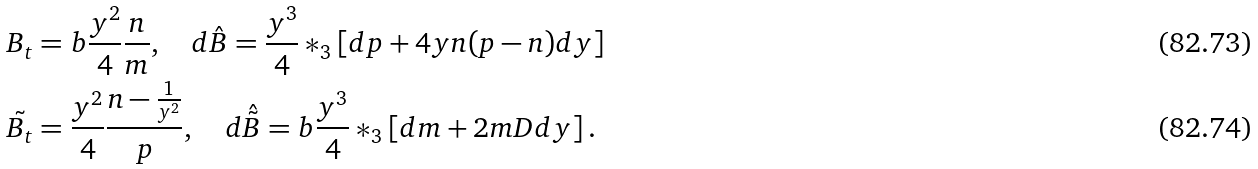<formula> <loc_0><loc_0><loc_500><loc_500>B _ { t } & = b \frac { y ^ { 2 } } { 4 } \frac { n } { m } , \quad d \hat { B } = \frac { y ^ { 3 } } { 4 } * _ { 3 } \left [ d p + 4 y n ( p - n ) d y \right ] \\ \tilde { B _ { t } } & = \frac { y ^ { 2 } } { 4 } \frac { n - \frac { 1 } { y ^ { 2 } } } { p } , \quad d \hat { \tilde { B } } = b \frac { y ^ { 3 } } { 4 } * _ { 3 } \left [ d m + 2 m D d y \right ] .</formula> 